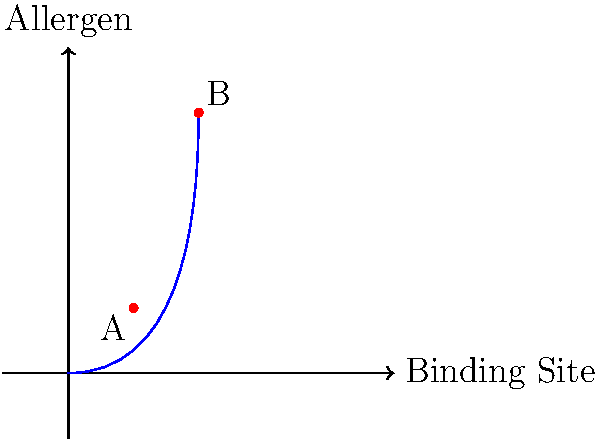Consider the molecular structure of a common food allergen and its binding site, as represented in the graph above. Point A represents a weak allergen-binding site interaction, while point B represents a strong interaction. What factor(s) could contribute to the increased binding affinity observed at point B compared to point A? To understand the difference in binding affinity between points A and B, we need to consider several factors:

1. Structural complementarity:
   - At point B, there is likely a better fit between the allergen and the binding site.
   - This improved fit can be due to the shape and size of the allergen matching the binding site more closely.

2. Intermolecular forces:
   - The stronger interaction at point B suggests more intermolecular forces are at play.
   - These could include:
     a) Hydrogen bonding: $\text{X}-\text{H}\cdots\text{Y}$
     b) Van der Waals forces
     c) Electrostatic interactions: $\text{q}_1\text{q}_2 / (4\pi\epsilon_0 r^2)$

3. Amino acid composition:
   - The binding site at point B may have a higher concentration of amino acids that favor interaction with the allergen.
   - For example, charged amino acids (Arg, Lys, Asp, Glu) can form salt bridges.

4. Conformational changes:
   - The allergen or binding site might undergo conformational changes upon interaction.
   - This could expose more binding residues, increasing the interaction strength.

5. Entropy and enthalpy:
   - The overall binding affinity is governed by the Gibbs free energy equation:
     $\Delta G = \Delta H - T\Delta S$
   - A more negative $\Delta G$ at point B would indicate stronger binding.

6. Specificity:
   - Point B may represent a more specific interaction, with fewer off-target binding possibilities.

The combination of these factors results in a higher binding affinity at point B, as indicated by its position higher on the curve in the graph.
Answer: Increased structural complementarity, stronger intermolecular forces, favorable amino acid composition, conformational changes, and more favorable thermodynamics. 